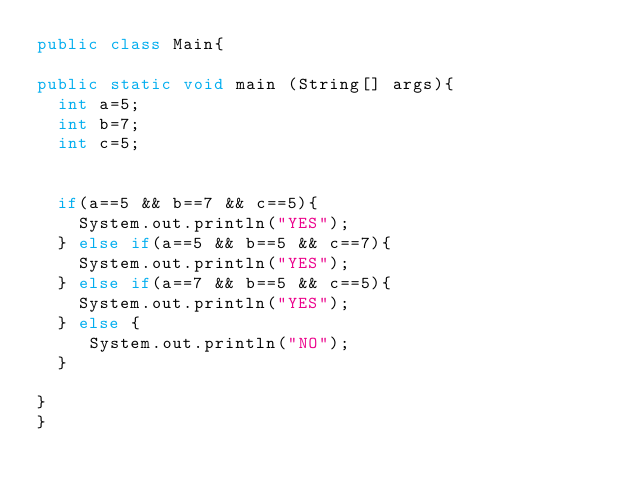Convert code to text. <code><loc_0><loc_0><loc_500><loc_500><_Java_>public class Main{

public static void main (String[] args){
  int a=5;
  int b=7;
  int c=5;
  
 
  if(a==5 && b==7 && c==5){
    System.out.println("YES");
  } else if(a==5 && b==5 && c==7){
    System.out.println("YES");
  } else if(a==7 && b==5 && c==5){
    System.out.println("YES");
  } else {
     System.out.println("NO");
  }
  
}
}
</code> 